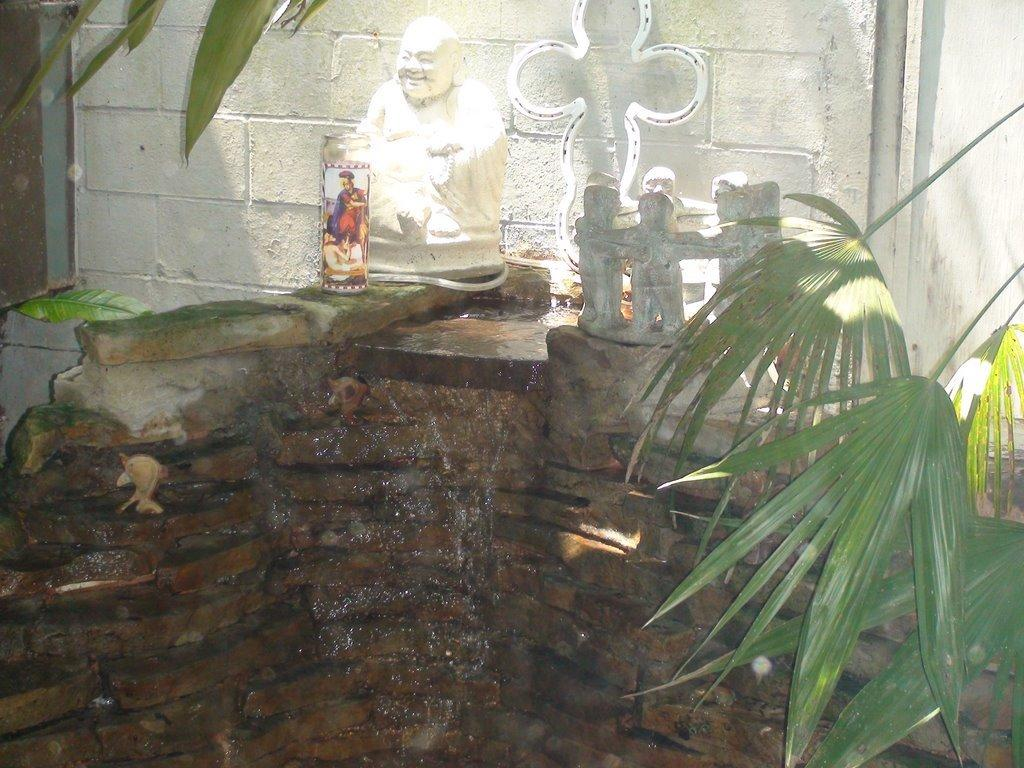What type of structure is present in the image? There is a rock fountain in the image. Is there any additional feature on the fountain? Yes, there is a statue on the fountain. What can be seen around the fountain and statue? The fountain and statue are surrounded by plants. What type of health advice can be seen on the statue in the image? There is no health advice present on the statue in the image. 